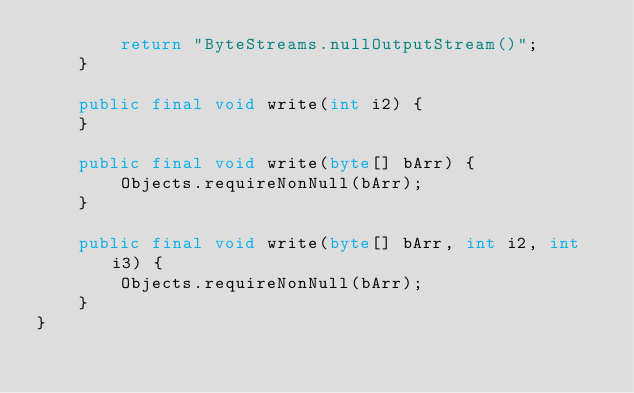Convert code to text. <code><loc_0><loc_0><loc_500><loc_500><_Java_>        return "ByteStreams.nullOutputStream()";
    }

    public final void write(int i2) {
    }

    public final void write(byte[] bArr) {
        Objects.requireNonNull(bArr);
    }

    public final void write(byte[] bArr, int i2, int i3) {
        Objects.requireNonNull(bArr);
    }
}
</code> 